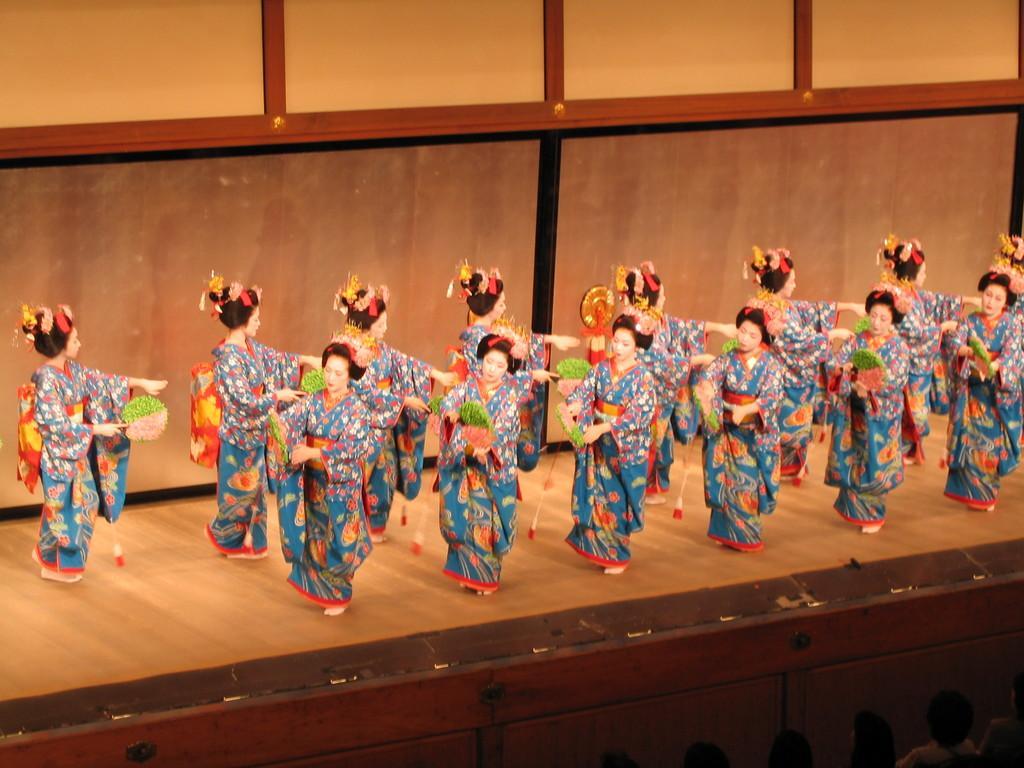Describe this image in one or two sentences. In the center of the image there are group of women performing on dais. At the bottom of the image there are persons. In the background there is a wall. 